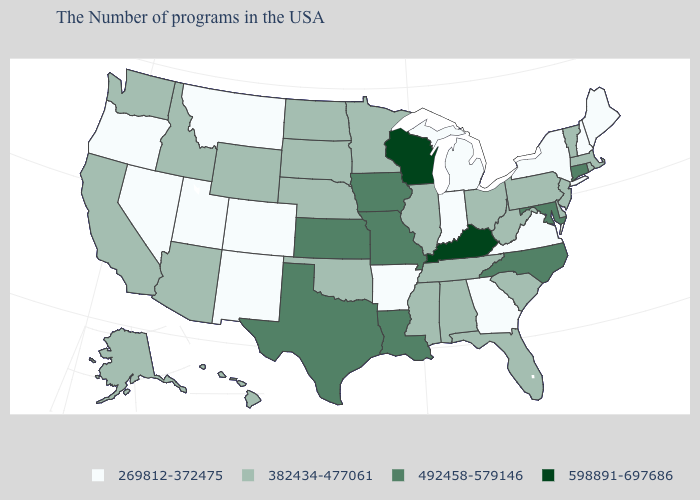What is the value of Connecticut?
Short answer required. 492458-579146. Name the states that have a value in the range 269812-372475?
Keep it brief. Maine, New Hampshire, New York, Virginia, Georgia, Michigan, Indiana, Arkansas, Colorado, New Mexico, Utah, Montana, Nevada, Oregon. What is the value of New Jersey?
Answer briefly. 382434-477061. What is the highest value in the USA?
Keep it brief. 598891-697686. What is the value of Arkansas?
Be succinct. 269812-372475. Name the states that have a value in the range 598891-697686?
Write a very short answer. Kentucky, Wisconsin. Does Arkansas have the highest value in the USA?
Concise answer only. No. Does Massachusetts have the same value as Tennessee?
Be succinct. Yes. Name the states that have a value in the range 382434-477061?
Concise answer only. Massachusetts, Rhode Island, Vermont, New Jersey, Delaware, Pennsylvania, South Carolina, West Virginia, Ohio, Florida, Alabama, Tennessee, Illinois, Mississippi, Minnesota, Nebraska, Oklahoma, South Dakota, North Dakota, Wyoming, Arizona, Idaho, California, Washington, Alaska, Hawaii. What is the value of Arizona?
Be succinct. 382434-477061. What is the value of Illinois?
Keep it brief. 382434-477061. Does Montana have a higher value than Texas?
Be succinct. No. What is the value of South Carolina?
Write a very short answer. 382434-477061. What is the value of Mississippi?
Give a very brief answer. 382434-477061. What is the value of Maine?
Concise answer only. 269812-372475. 